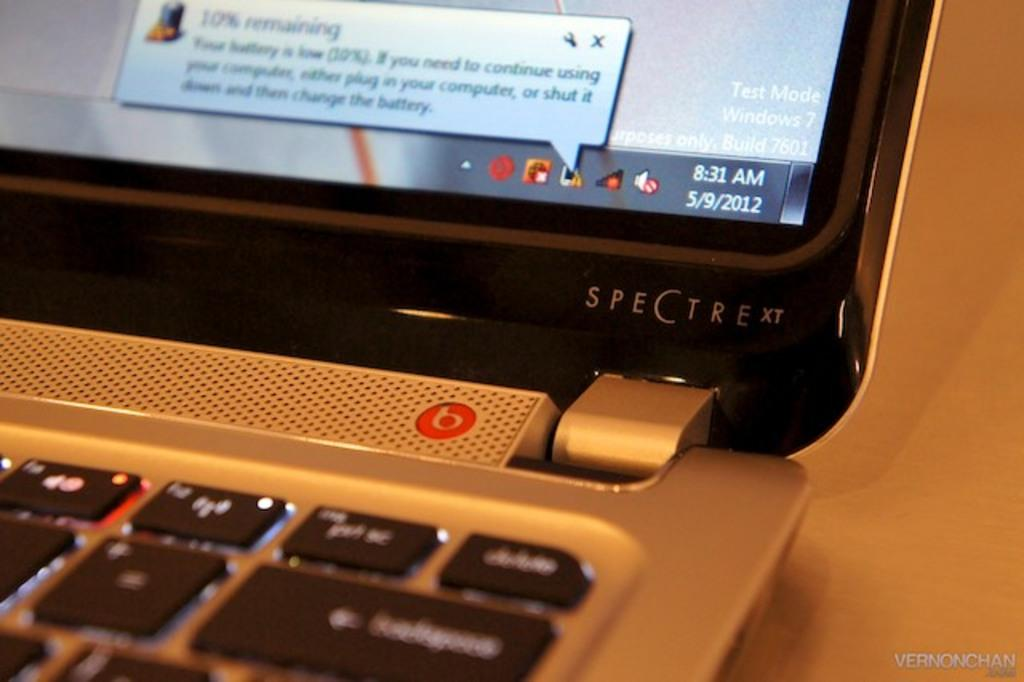<image>
Write a terse but informative summary of the picture. A laptop computer running Microsoft Windows is identified by the name Spectre XT. 